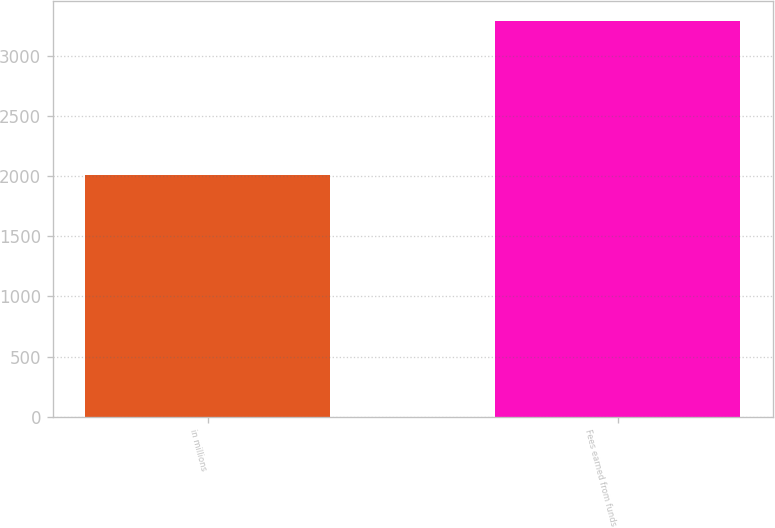<chart> <loc_0><loc_0><loc_500><loc_500><bar_chart><fcel>in millions<fcel>Fees earned from funds<nl><fcel>2015<fcel>3293<nl></chart> 